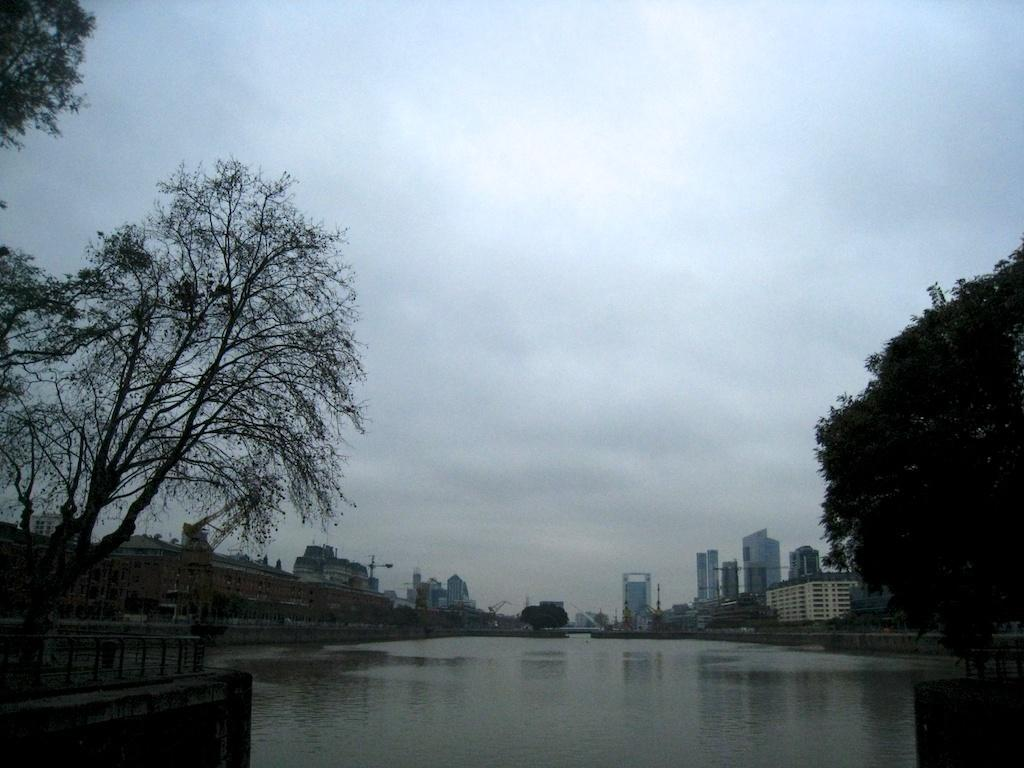What is the main subject in the center of the image? There is water in the center of the image. What type of natural elements can be seen in the image? There are trees in the image. What man-made structures are present in the image? There is a fence and a wall in the image. What can be seen in the background of the image? The sky, clouds, buildings, and poles are visible in the background of the image. What type of calculator is floating in the water in the image? There is no calculator present in the image; it only features water, trees, fence, wall, and background elements. Can you describe the body language of the person in the image? There is no person present in the image, so it is not possible to describe their body language. 